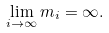<formula> <loc_0><loc_0><loc_500><loc_500>\lim _ { i \to \infty } m _ { i } = \infty .</formula> 